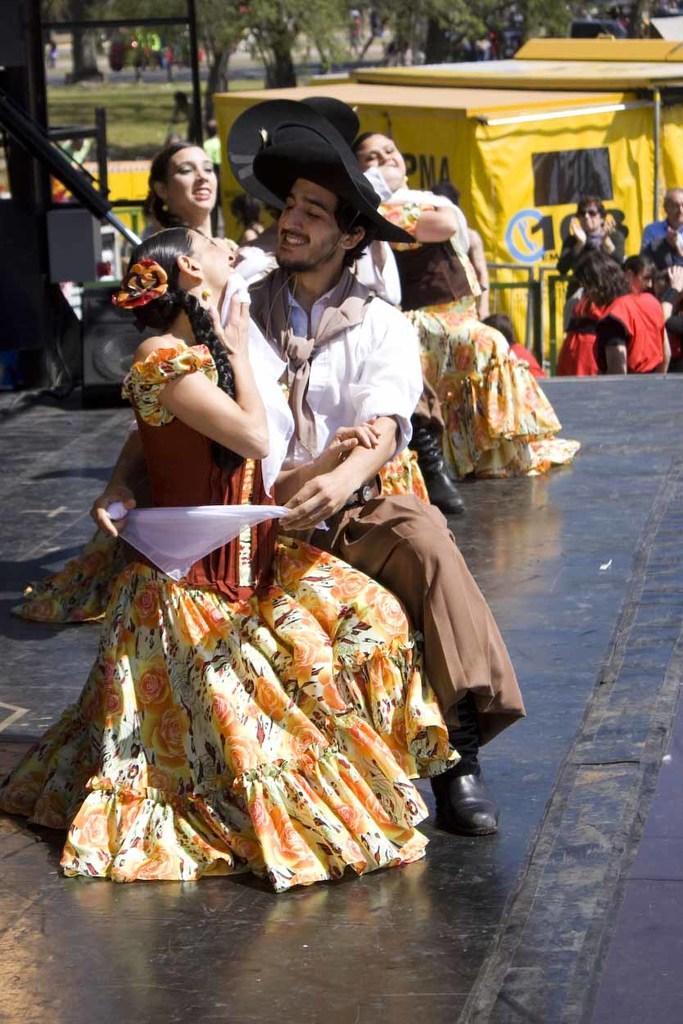In one or two sentences, can you explain what this image depicts? Here we can see couples dancing on the stage. In the background there are few persons standing, poles, trees and grass on the ground, room and other objects are not clear. 